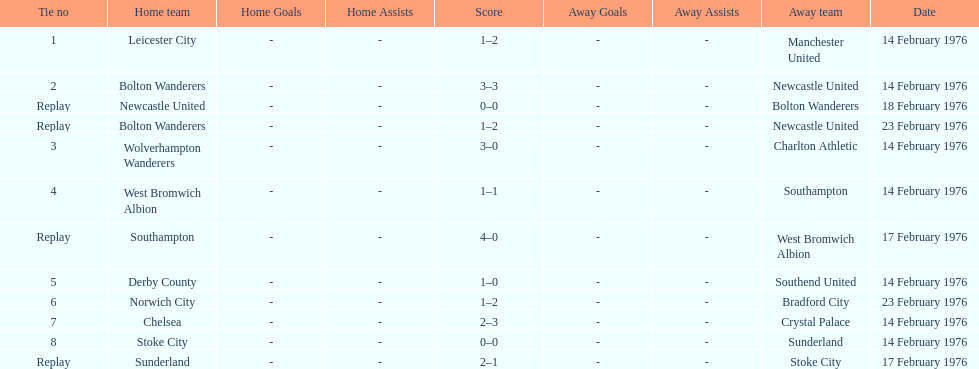What is the number of games that were played again? 4. 